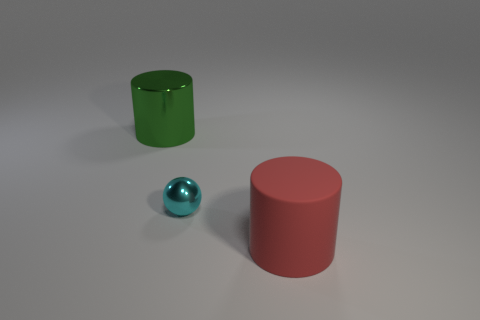Are there any other things that have the same material as the big red object?
Your answer should be very brief. No. What color is the small thing?
Provide a short and direct response. Cyan. What number of large objects are red matte things or green metal cylinders?
Give a very brief answer. 2. What is the shape of the metallic thing right of the green cylinder?
Give a very brief answer. Sphere. Are there fewer small yellow objects than big green metal objects?
Make the answer very short. Yes. Do the big cylinder that is to the left of the large red rubber cylinder and the large red thing have the same material?
Make the answer very short. No. Are there any other things that have the same size as the cyan thing?
Keep it short and to the point. No. There is a green metallic cylinder; are there any things right of it?
Keep it short and to the point. Yes. What is the color of the large cylinder behind the metal thing that is on the right side of the green metal cylinder behind the cyan metallic thing?
Make the answer very short. Green. The metallic thing that is the same size as the red matte cylinder is what shape?
Provide a succinct answer. Cylinder. 